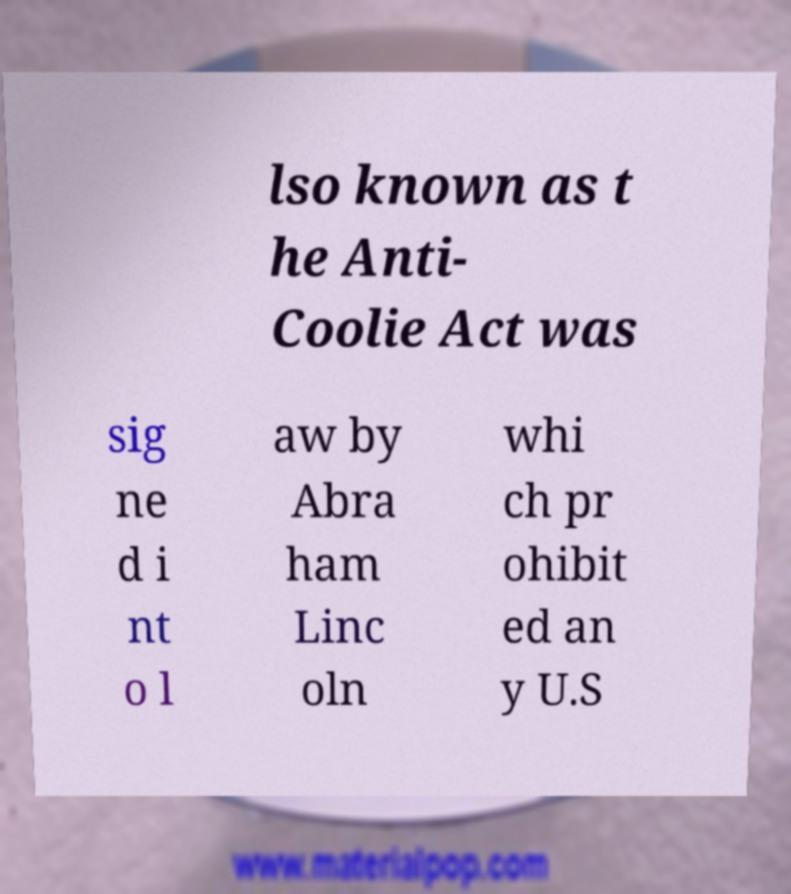I need the written content from this picture converted into text. Can you do that? lso known as t he Anti- Coolie Act was sig ne d i nt o l aw by Abra ham Linc oln whi ch pr ohibit ed an y U.S 